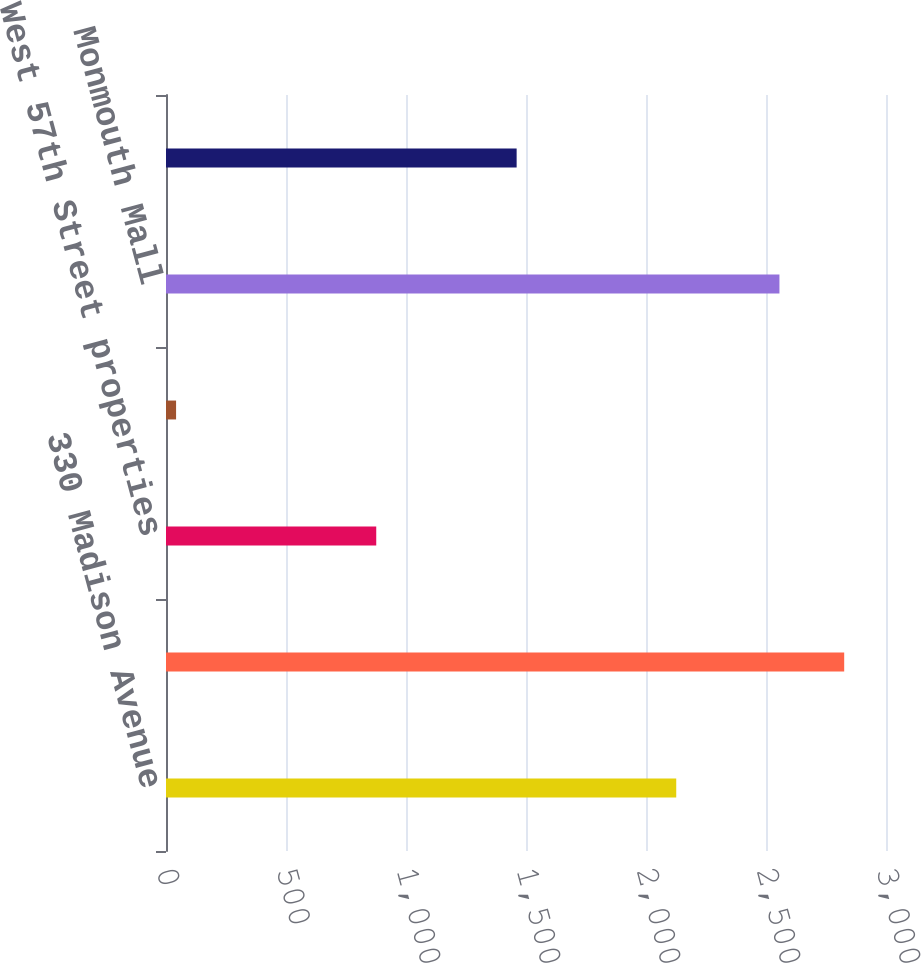<chart> <loc_0><loc_0><loc_500><loc_500><bar_chart><fcel>330 Madison Avenue<fcel>1101 17th Street<fcel>West 57th Street properties<fcel>Fairfax Square<fcel>Monmouth Mall<fcel>Downtown Crossing Boston<nl><fcel>2126<fcel>2825.8<fcel>876<fcel>42<fcel>2556<fcel>1461<nl></chart> 